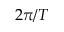Convert formula to latex. <formula><loc_0><loc_0><loc_500><loc_500>2 \pi / T</formula> 